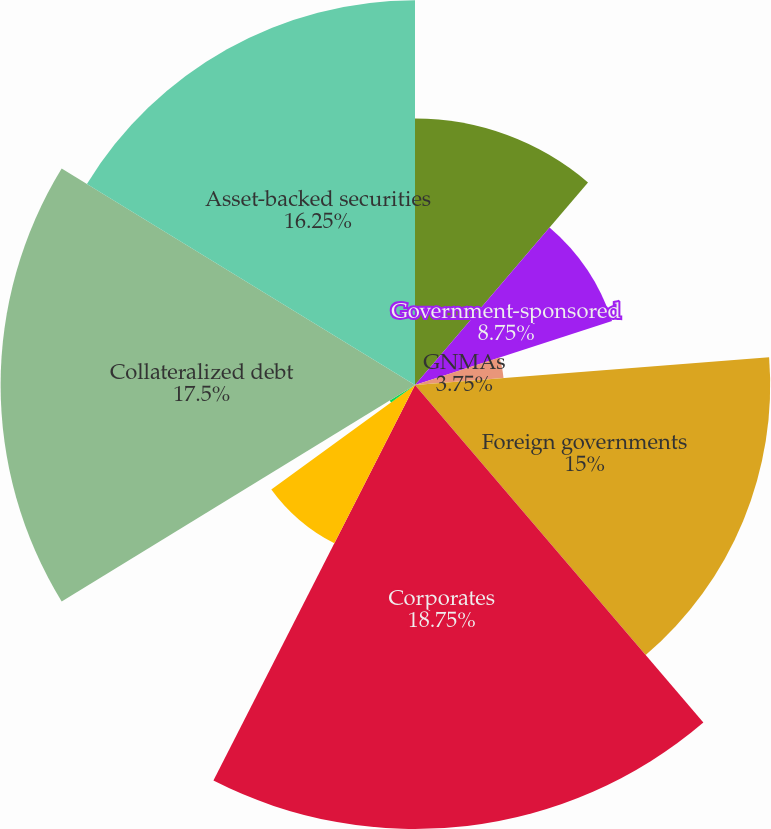Convert chart to OTSL. <chart><loc_0><loc_0><loc_500><loc_500><pie_chart><fcel>US Government and agencies<fcel>Government-sponsored<fcel>GNMAs<fcel>States municipalities and<fcel>Foreign governments<fcel>Corporates<fcel>Residential mortgage-backed<fcel>Commercial mortgage-backed<fcel>Collateralized debt<fcel>Asset-backed securities<nl><fcel>11.25%<fcel>8.75%<fcel>3.75%<fcel>0.0%<fcel>15.0%<fcel>18.75%<fcel>7.5%<fcel>1.25%<fcel>17.5%<fcel>16.25%<nl></chart> 